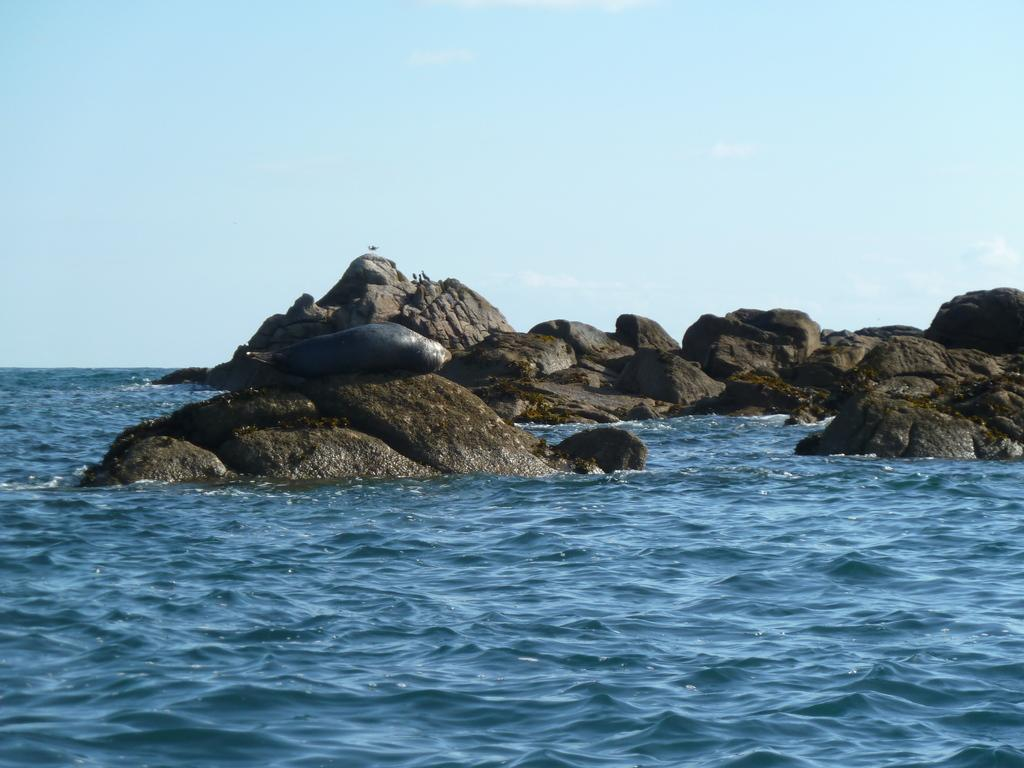What type of natural elements can be seen in the image? There are rocks and water visible in the image. What is visible at the top of the image? The sky is visible at the top of the image. How many books can be seen on the rocks in the image? There are no books present in the image; it features rocks and water. What type of mice can be seen interacting with the water in the image? There are no mice present in the image; it features rocks and water. 